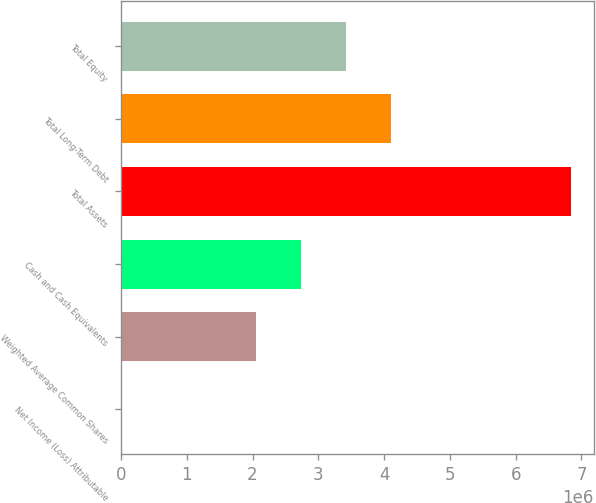<chart> <loc_0><loc_0><loc_500><loc_500><bar_chart><fcel>Net Income (Loss) Attributable<fcel>Weighted Average Common Shares<fcel>Cash and Cash Equivalents<fcel>Total Assets<fcel>Total Long-Term Debt<fcel>Total Equity<nl><fcel>1.08<fcel>2.05405e+06<fcel>2.73873e+06<fcel>6.84683e+06<fcel>4.1081e+06<fcel>3.42342e+06<nl></chart> 